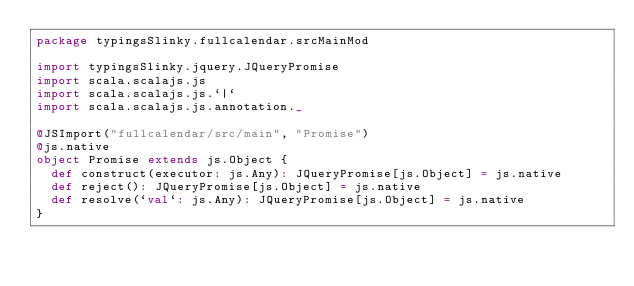<code> <loc_0><loc_0><loc_500><loc_500><_Scala_>package typingsSlinky.fullcalendar.srcMainMod

import typingsSlinky.jquery.JQueryPromise
import scala.scalajs.js
import scala.scalajs.js.`|`
import scala.scalajs.js.annotation._

@JSImport("fullcalendar/src/main", "Promise")
@js.native
object Promise extends js.Object {
  def construct(executor: js.Any): JQueryPromise[js.Object] = js.native
  def reject(): JQueryPromise[js.Object] = js.native
  def resolve(`val`: js.Any): JQueryPromise[js.Object] = js.native
}

</code> 